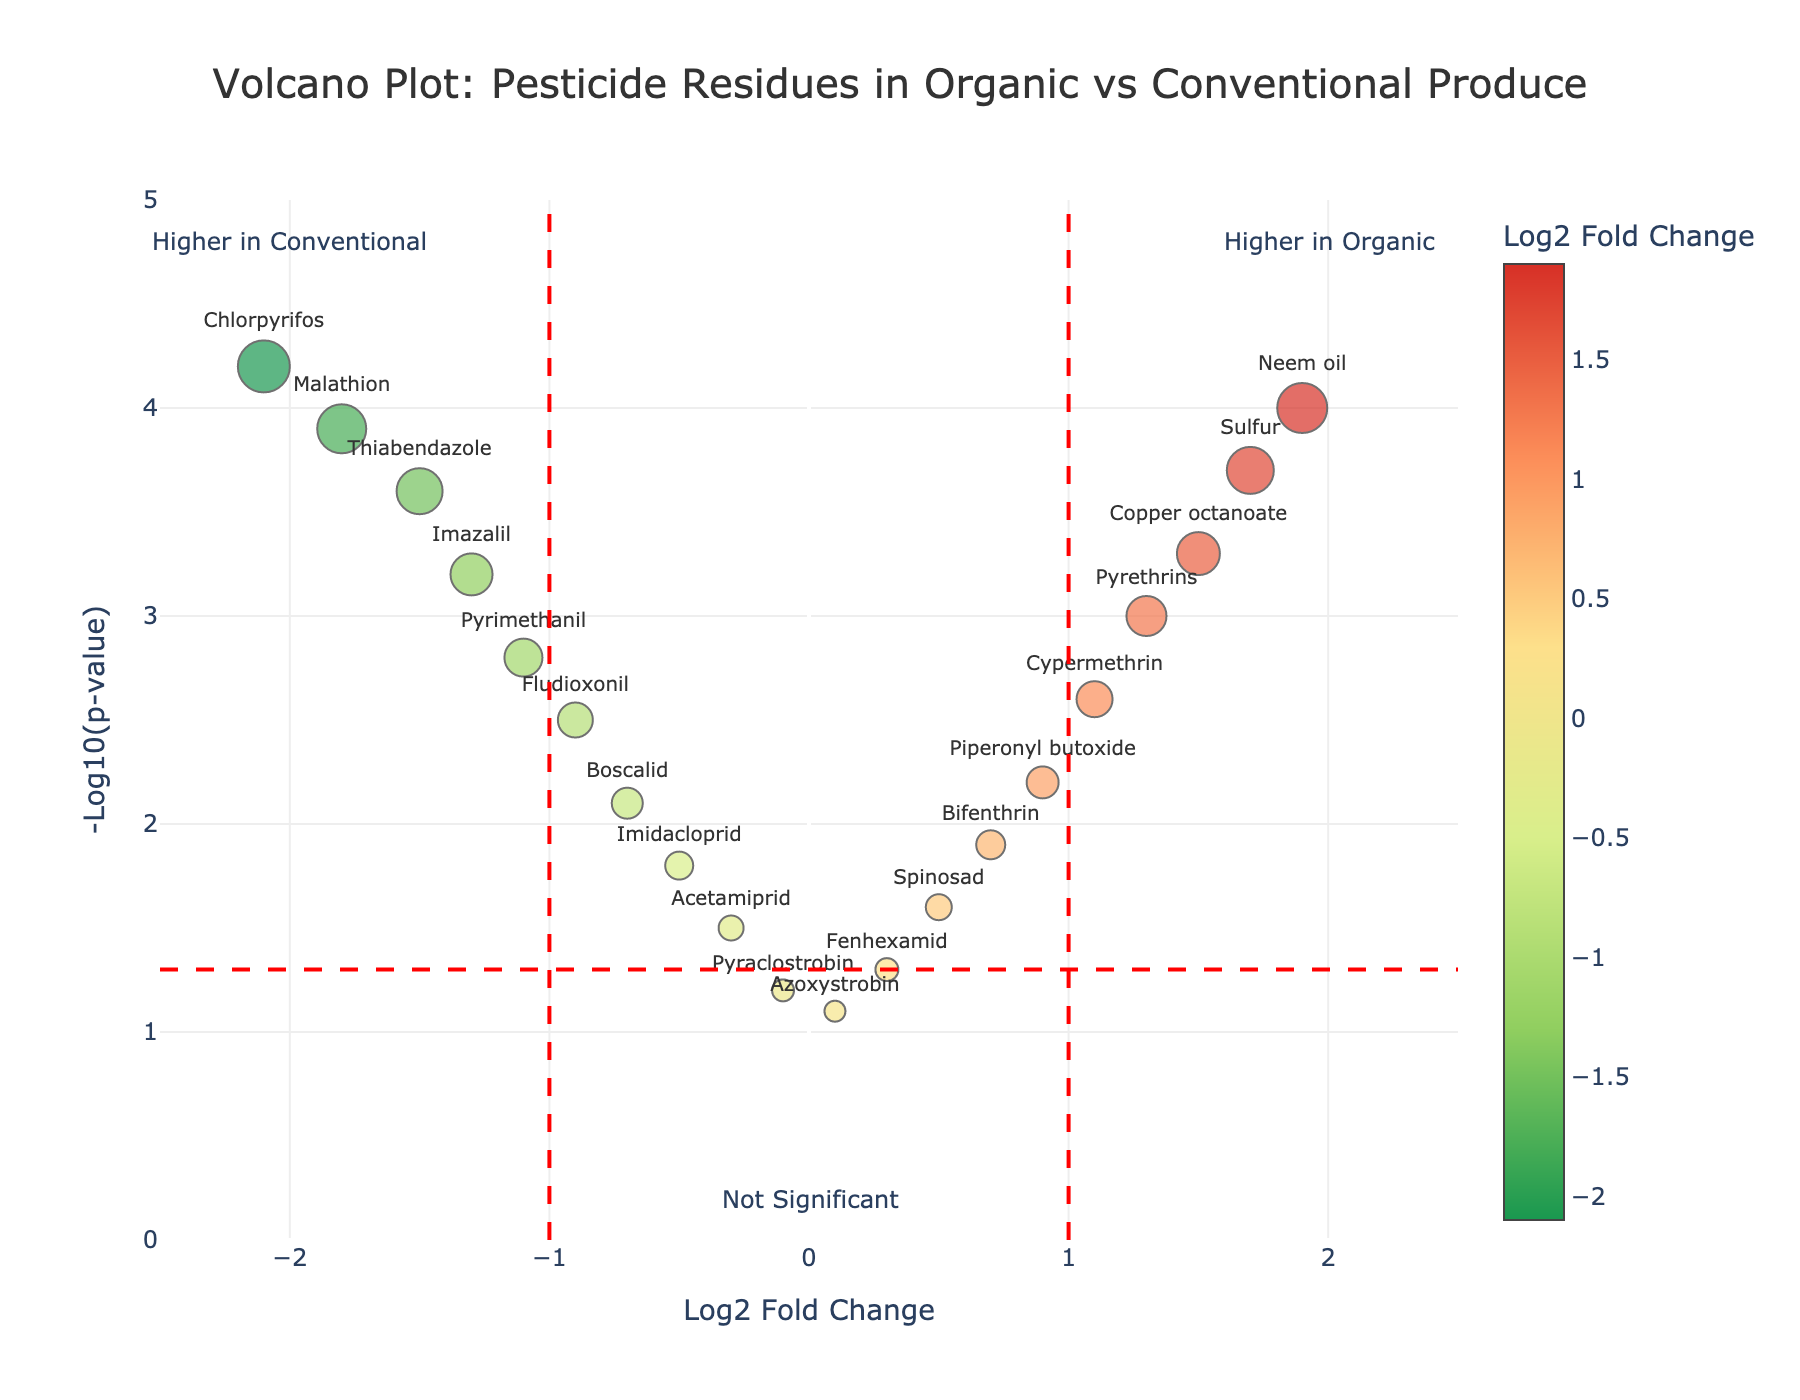What is the title of the figure? The title of the figure is usually located at the top and clearly specifies what the plot is about. In this case, it states: "Volcano Plot: Pesticide Residues in Organic vs Conventional Produce"
Answer: Volcano Plot: Pesticide Residues in Organic vs Conventional Produce What does a Log2 Fold Change of -2.1 signify in terms of pesticide concentration difference? Log2 Fold Change indicates how much more concentrated a pesticide is in one condition. A Log2 Fold Change of -2.1 means the pesticide (Chlorpyrifos) concentration is 2^2.1 (approximately 4.29) times higher in conventional produce than in organic produce
Answer: Concentration is about 4.29 times higher in conventional Which pesticide shows the highest -Log10(p-value)? The highest -Log10(p-value) can be identified by looking at the data point that appears highest on the y-axis in the plot. In this plot, Chlorpyrifos has the highest -Log10(p-value) of 4.2
Answer: Chlorpyrifos What do the vertical dashed lines at -1 and 1 Log2 Fold Change represent? Vertical dashed lines often represent thresholds or cutoffs. Here, lines at -1 and 1 indicate fold changes considered significant. Points to the left of -1 indicate higher concentration in conventional produce, while points to the right of 1 indicate higher concentration in organic produce
Answer: Significant fold change thresholds Which pesticides are higher in organic produce and statistically significant? Pesticides higher in organic produce would have a positive Log2 Fold Change greater than 1 and significant if -Log10(p-value) is above 1.3. These points are found in the upper right quadrant beyond the vertical line at Log2 Fold Change = 1
Answer: Cypermethrin, Pyrethrins, Copper octanoate, Sulfur, Neem oil What is the color gradient representing in the plot? The color gradient in the plot represents the Log2 Fold Change values. Usually, different colors indicate various levels of fold change, helping to identify the degree of concentration difference between organic and conventional produce
Answer: Log2 Fold Change values How many pesticides show higher concentrations in conventional produce and are statistically significant? Pesticides higher in conventional produce would have a negative Log2 Fold Change less than -1 and -Log10(p-value) above 1.3. These points are found in the upper left quadrant beyond the vertical line at Log2 Fold Change = -1
Answer: Three pesticides (Chlorpyrifos, Malathion, Thiabendazole) Explain the significance of a data point located at (0, 1.2). A data point at (0, 1.2) indicates no fold change in concentration between organic and conventional produce (Log2 Fold Change = 0), and a -Log10(p-value) of 1.2 means the difference isn't statistically significant (p-value≈0.07)
Answer: No significant difference Which pesticide has a Log2 Fold Change of 0.3 and what does it mean? By referring to the data points labeled in the plot, Fenhexamid is the pesticide with Log2 Fold Change of 0.3. This means the concentration of Fenhexamid in organic produce is approximately 1.23 times that in conventional produce
Answer: Fenhexamid; concentration is about 1.23 times higher in organic What inference can you make from pesticides spots around (0, >4)? Pesticides around (0, >4) show little to no fold change (Log2 Fold Change≈0) and a highly significant difference (-Log10(p-value) > 4). This means that while the concentration differences are minimal, they are statistically very significant
Answer: Minimal but statistically significant differences 